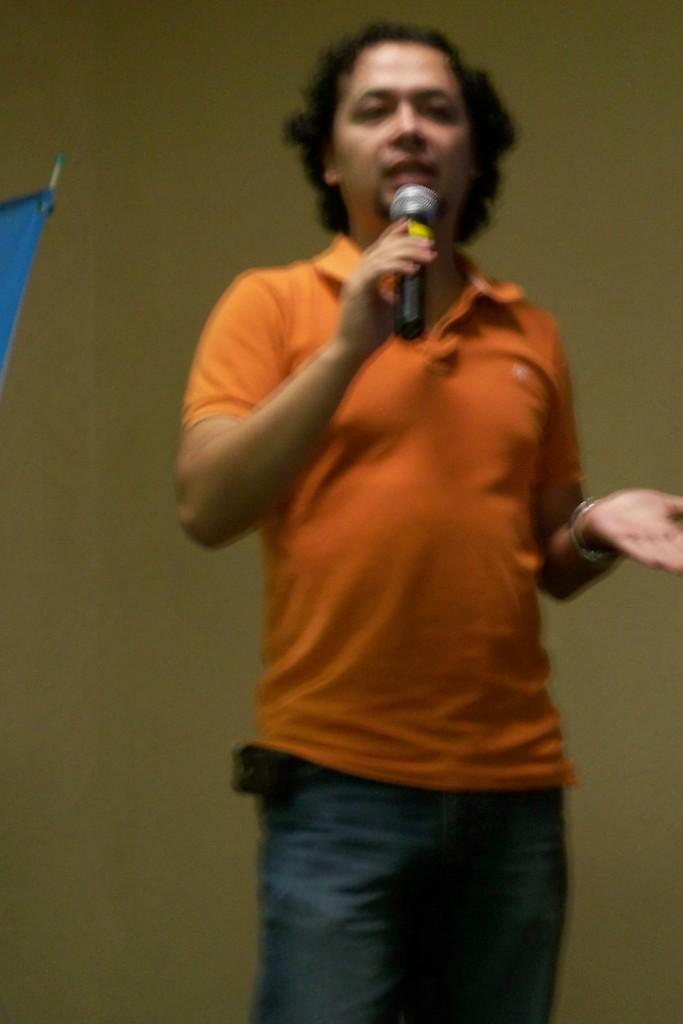Who is present in the image? There is a man in the image. What is the man wearing? The man is wearing an orange t-shirt. What is the man holding in the image? The man is holding a mic. What can be seen in the background of the image? There is a wall in the background of the image. How many ladybugs are crawling on the man's orange t-shirt in the image? There are no ladybugs present on the man's orange t-shirt in the image. 